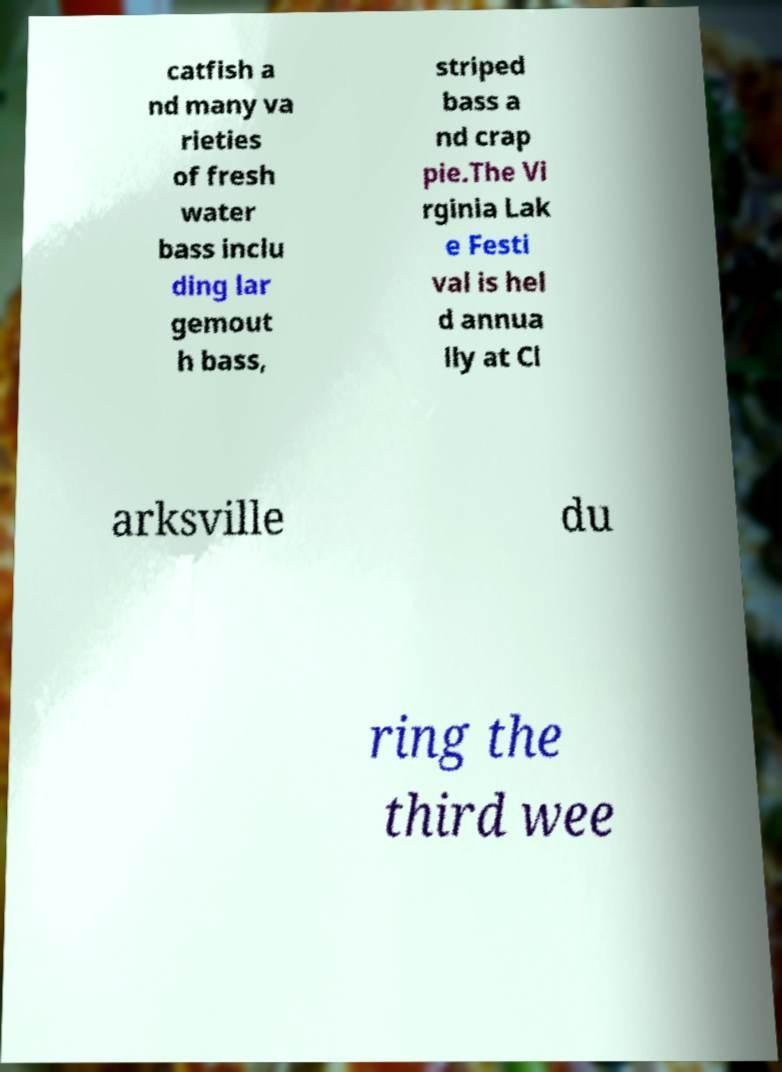Can you read and provide the text displayed in the image?This photo seems to have some interesting text. Can you extract and type it out for me? catfish a nd many va rieties of fresh water bass inclu ding lar gemout h bass, striped bass a nd crap pie.The Vi rginia Lak e Festi val is hel d annua lly at Cl arksville du ring the third wee 